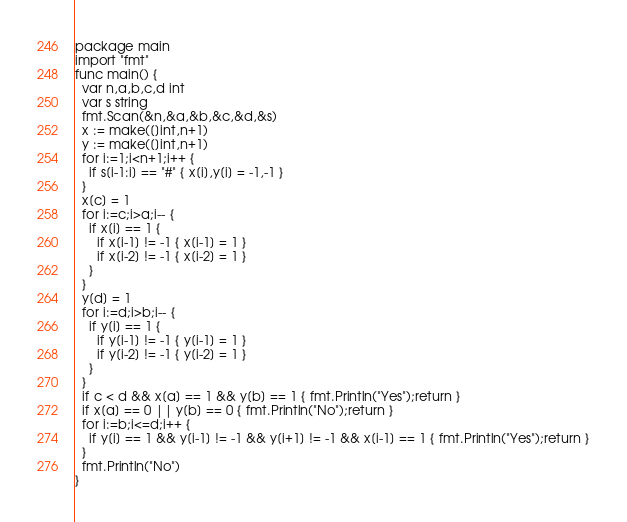Convert code to text. <code><loc_0><loc_0><loc_500><loc_500><_Go_>package main
import "fmt"
func main() {
  var n,a,b,c,d int
  var s string
  fmt.Scan(&n,&a,&b,&c,&d,&s)
  x := make([]int,n+1)
  y := make([]int,n+1)
  for i:=1;i<n+1;i++ {
    if s[i-1:i] == "#" { x[i],y[i] = -1,-1 }
  }
  x[c] = 1
  for i:=c;i>a;i-- {
    if x[i] == 1 {
      if x[i-1] != -1 { x[i-1] = 1 }
      if x[i-2] != -1 { x[i-2] = 1 }
    }
  }
  y[d] = 1
  for i:=d;i>b;i-- {
    if y[i] == 1 {
      if y[i-1] != -1 { y[i-1] = 1 }
      if y[i-2] != -1 { y[i-2] = 1 }
    }
  }
  if c < d && x[a] == 1 && y[b] == 1 { fmt.Println("Yes");return }
  if x[a] == 0 || y[b] == 0 { fmt.Println("No");return }
  for i:=b;i<=d;i++ {
    if y[i] == 1 && y[i-1] != -1 && y[i+1] != -1 && x[i-1] == 1 { fmt.Println("Yes");return }
  }
  fmt.Println("No")
}</code> 